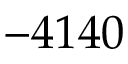Convert formula to latex. <formula><loc_0><loc_0><loc_500><loc_500>- 4 1 4 0</formula> 